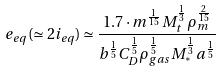Convert formula to latex. <formula><loc_0><loc_0><loc_500><loc_500>e _ { e q } ( \simeq 2 i _ { e q } ) \simeq \frac { 1 . 7 \cdot m ^ { \frac { 1 } { 1 5 } } M _ { t } ^ { \frac { 1 } { 3 } } \rho _ { m } ^ { \frac { 2 } { 1 5 } } } { b ^ { \frac { 1 } { 5 } } C _ { D } ^ { \frac { 1 } { 5 } } \rho _ { g a s } ^ { \frac { 1 } { 5 } } M _ { ^ { * } } ^ { \frac { 1 } { 3 } } a ^ { \frac { 1 } { 5 } } }</formula> 